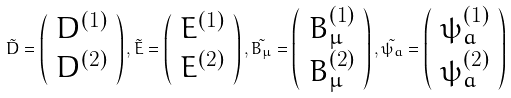<formula> <loc_0><loc_0><loc_500><loc_500>\tilde { D } = \left ( \begin{array} { c } { { D ^ { ( 1 ) } } } \\ { { D ^ { ( 2 ) } } } \end{array} \right ) , \tilde { E } = \left ( \begin{array} { c } { { E ^ { ( 1 ) } } } \\ { { E ^ { ( 2 ) } } } \end{array} \right ) , \tilde { B _ { \mu } } = \left ( \begin{array} { c } { { B _ { \mu } ^ { ( 1 ) } } } \\ { { B _ { \mu } ^ { ( 2 ) } } } \end{array} \right ) , \tilde { \psi _ { a } } = \left ( \begin{array} { c } { { \psi _ { a } ^ { ( 1 ) } } } \\ { { \psi _ { a } ^ { ( 2 ) } } } \end{array} \right )</formula> 